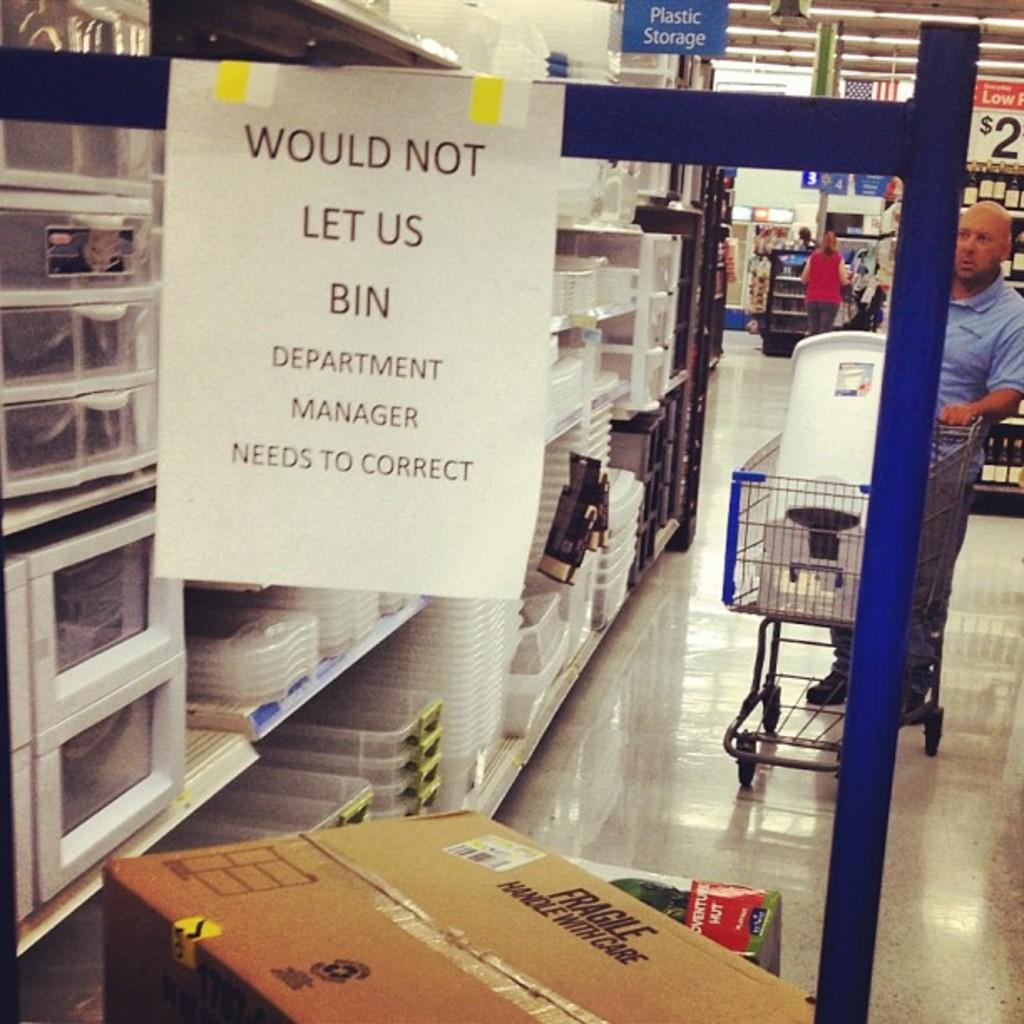<image>
Offer a succinct explanation of the picture presented. A customer looks through the shelves in a Plastic Storage section 